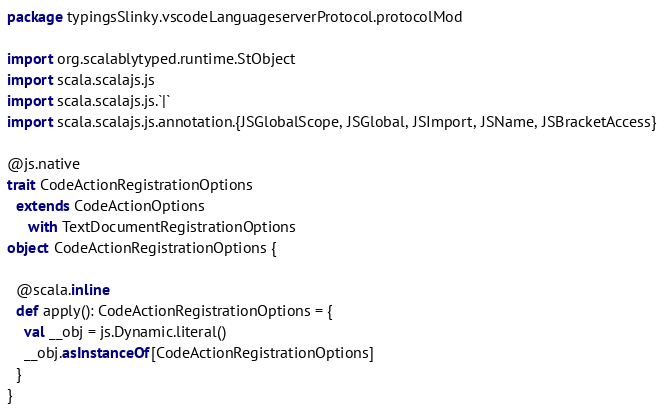<code> <loc_0><loc_0><loc_500><loc_500><_Scala_>package typingsSlinky.vscodeLanguageserverProtocol.protocolMod

import org.scalablytyped.runtime.StObject
import scala.scalajs.js
import scala.scalajs.js.`|`
import scala.scalajs.js.annotation.{JSGlobalScope, JSGlobal, JSImport, JSName, JSBracketAccess}

@js.native
trait CodeActionRegistrationOptions
  extends CodeActionOptions
     with TextDocumentRegistrationOptions
object CodeActionRegistrationOptions {
  
  @scala.inline
  def apply(): CodeActionRegistrationOptions = {
    val __obj = js.Dynamic.literal()
    __obj.asInstanceOf[CodeActionRegistrationOptions]
  }
}
</code> 